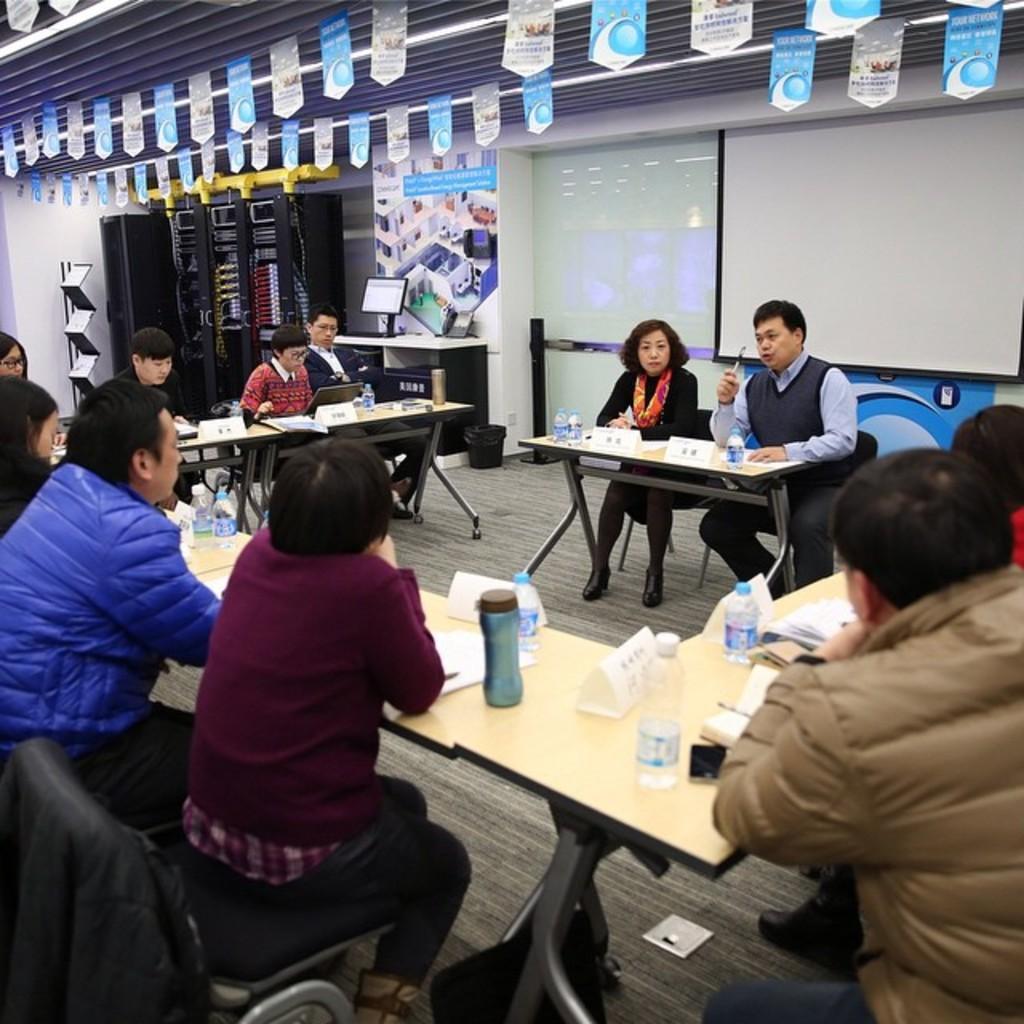How would you summarize this image in a sentence or two? In the picture there are many people sitting on the chair with the table in front of them on the table there are many bottles papers laptops books on the roof there are many paper flags on the wall there is a banner on the banner there is a text. 